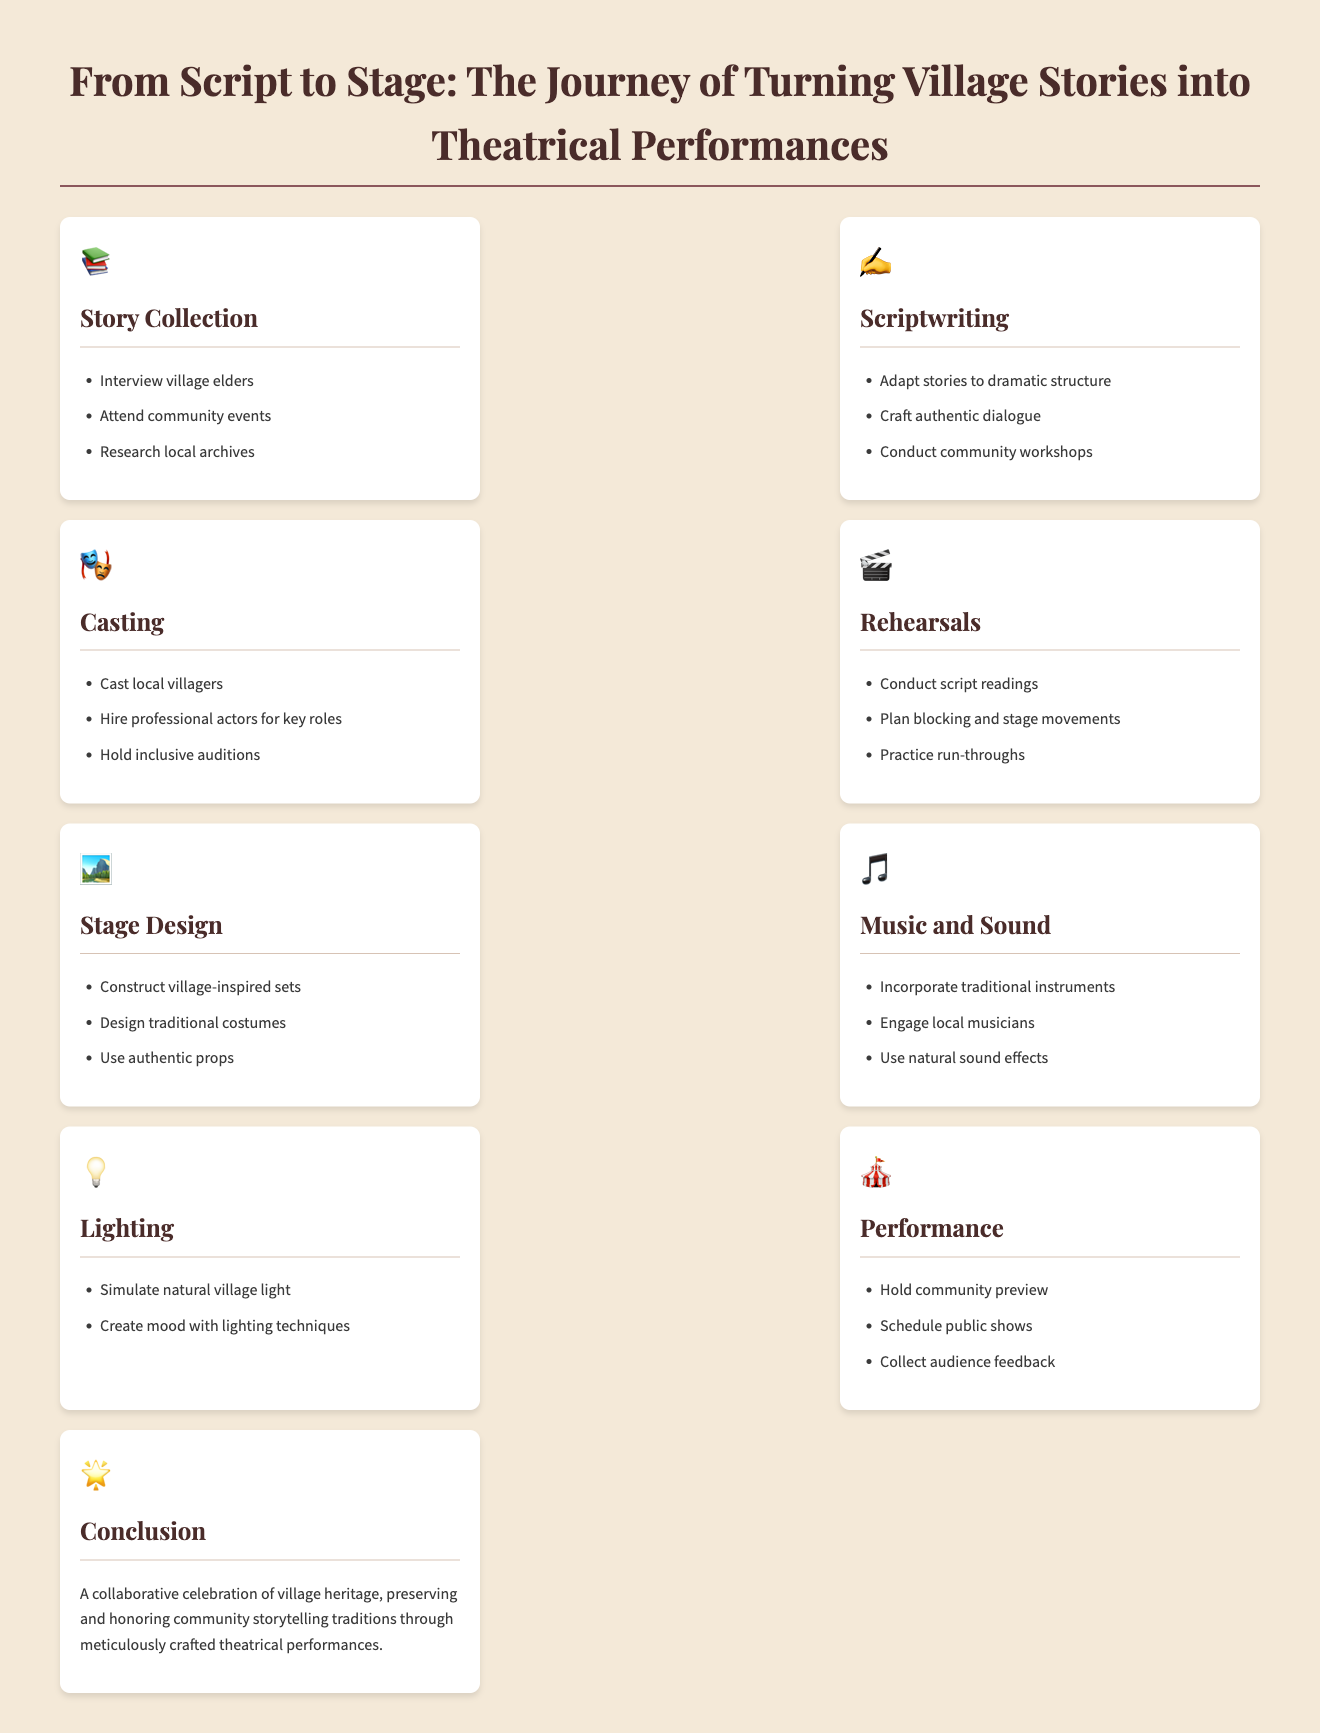what is the first step in the journey from script to stage? The first step outlined in the infographic is story collection, involving interviewing village elders, attending community events, and researching local archives.
Answer: story collection which icon represents rehearsals? The rehearsal section is represented by the icon of a clapperboard, which is commonly associated with acting and film production.
Answer: 🎬 how many sections are there in the infographic? The infographic features a total of nine distinct sections, each focusing on a different aspect of the theatrical process.
Answer: nine what does the conclusion emphasize? The conclusion emphasizes a collaborative celebration of village heritage through theatrical performances that honor community storytelling traditions.
Answer: collaborative celebration of village heritage which activity involves community workshops? Community workshops are part of the scriptwriting process, where stories are adapted and authentic dialogue is crafted.
Answer: scriptwriting what types of lighting techniques are mentioned? The infographic mentions simulating natural village light and creating mood with various lighting techniques in the lighting section.
Answer: natural village light and mood creation who engages local musicians? The music and sound section indicates that it is the responsibility of the production team to engage local musicians for the performances.
Answer: production team what must be done before public shows? Before public shows, a community preview must be held to gather initial audience reactions and feedback.
Answer: community preview 